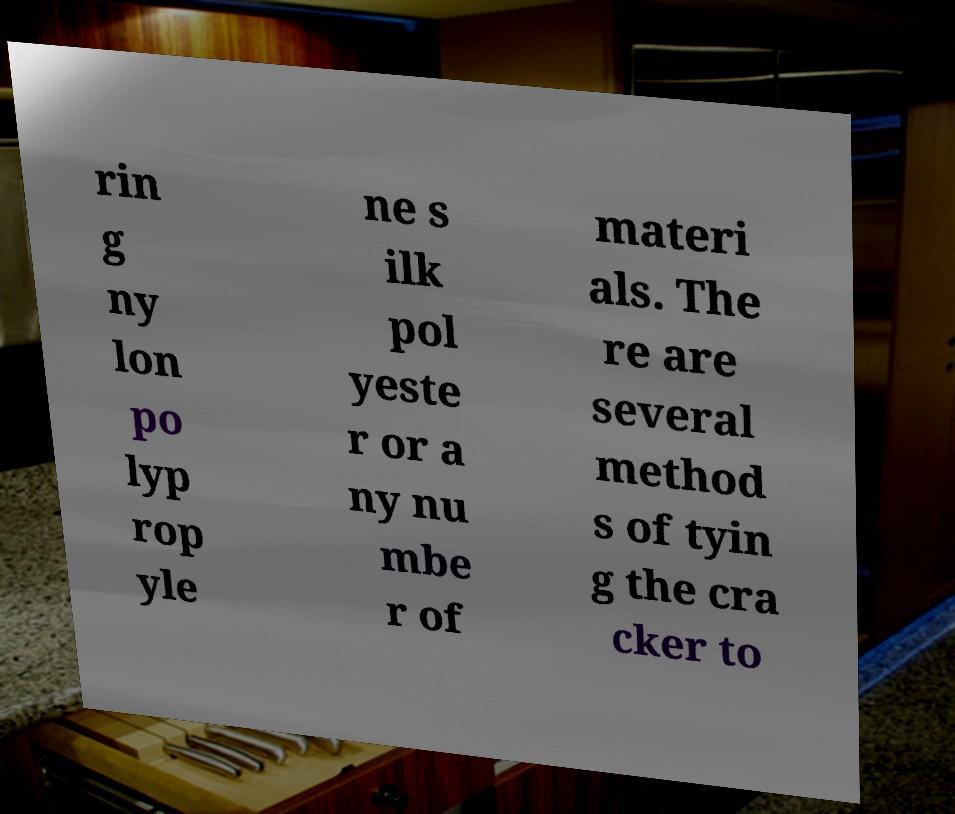What messages or text are displayed in this image? I need them in a readable, typed format. rin g ny lon po lyp rop yle ne s ilk pol yeste r or a ny nu mbe r of materi als. The re are several method s of tyin g the cra cker to 